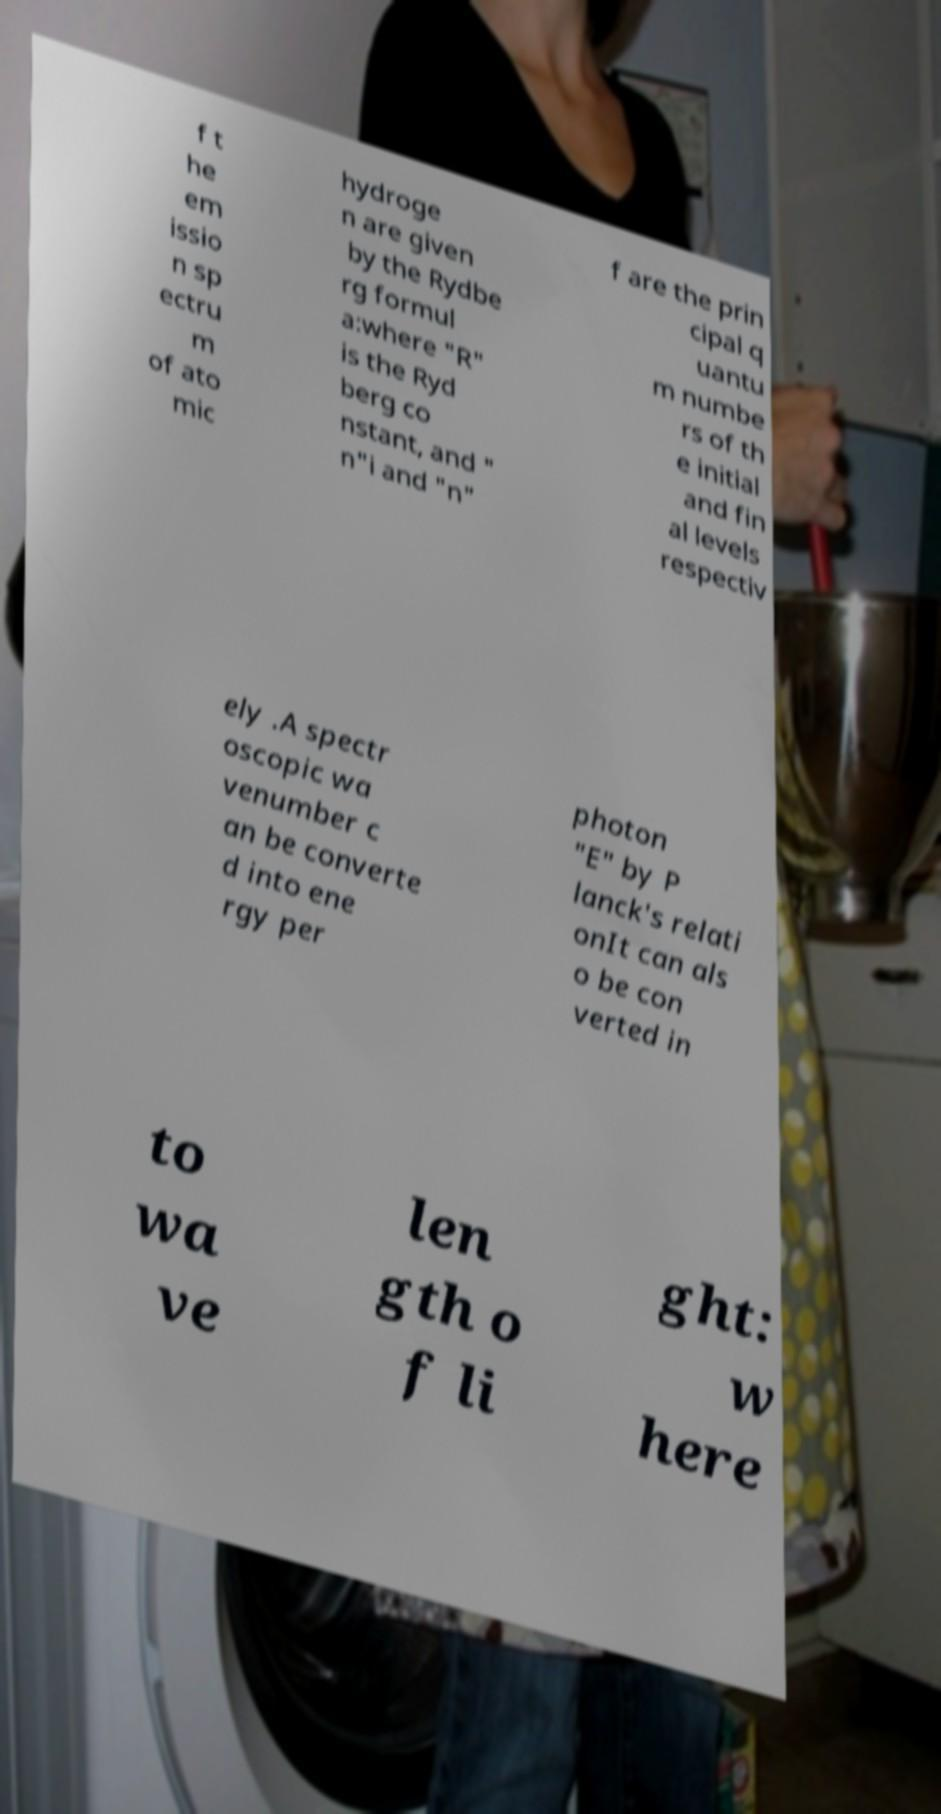Can you accurately transcribe the text from the provided image for me? f t he em issio n sp ectru m of ato mic hydroge n are given by the Rydbe rg formul a:where "R" is the Ryd berg co nstant, and " n"i and "n" f are the prin cipal q uantu m numbe rs of th e initial and fin al levels respectiv ely .A spectr oscopic wa venumber c an be converte d into ene rgy per photon "E" by P lanck's relati onIt can als o be con verted in to wa ve len gth o f li ght: w here 